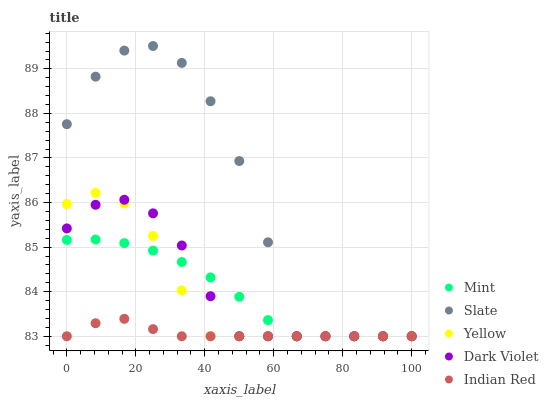Does Indian Red have the minimum area under the curve?
Answer yes or no. Yes. Does Slate have the maximum area under the curve?
Answer yes or no. Yes. Does Mint have the minimum area under the curve?
Answer yes or no. No. Does Mint have the maximum area under the curve?
Answer yes or no. No. Is Indian Red the smoothest?
Answer yes or no. Yes. Is Slate the roughest?
Answer yes or no. Yes. Is Mint the smoothest?
Answer yes or no. No. Is Mint the roughest?
Answer yes or no. No. Does Indian Red have the lowest value?
Answer yes or no. Yes. Does Slate have the highest value?
Answer yes or no. Yes. Does Mint have the highest value?
Answer yes or no. No. Does Yellow intersect Mint?
Answer yes or no. Yes. Is Yellow less than Mint?
Answer yes or no. No. Is Yellow greater than Mint?
Answer yes or no. No. 